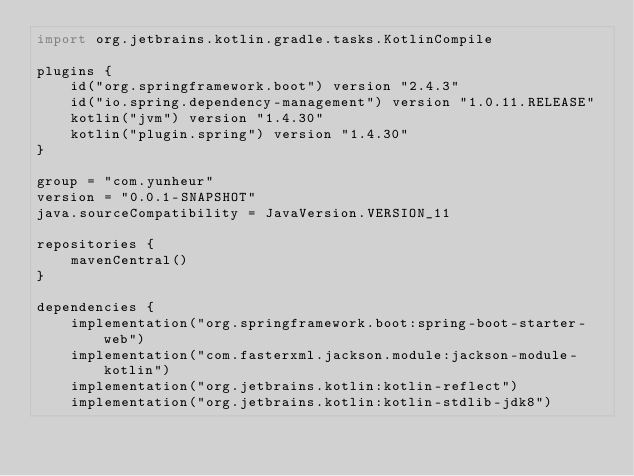<code> <loc_0><loc_0><loc_500><loc_500><_Kotlin_>import org.jetbrains.kotlin.gradle.tasks.KotlinCompile

plugins {
	id("org.springframework.boot") version "2.4.3"
	id("io.spring.dependency-management") version "1.0.11.RELEASE"
	kotlin("jvm") version "1.4.30"
	kotlin("plugin.spring") version "1.4.30"
}

group = "com.yunheur"
version = "0.0.1-SNAPSHOT"
java.sourceCompatibility = JavaVersion.VERSION_11

repositories {
	mavenCentral()
}

dependencies {
	implementation("org.springframework.boot:spring-boot-starter-web")
	implementation("com.fasterxml.jackson.module:jackson-module-kotlin")
	implementation("org.jetbrains.kotlin:kotlin-reflect")
	implementation("org.jetbrains.kotlin:kotlin-stdlib-jdk8")</code> 